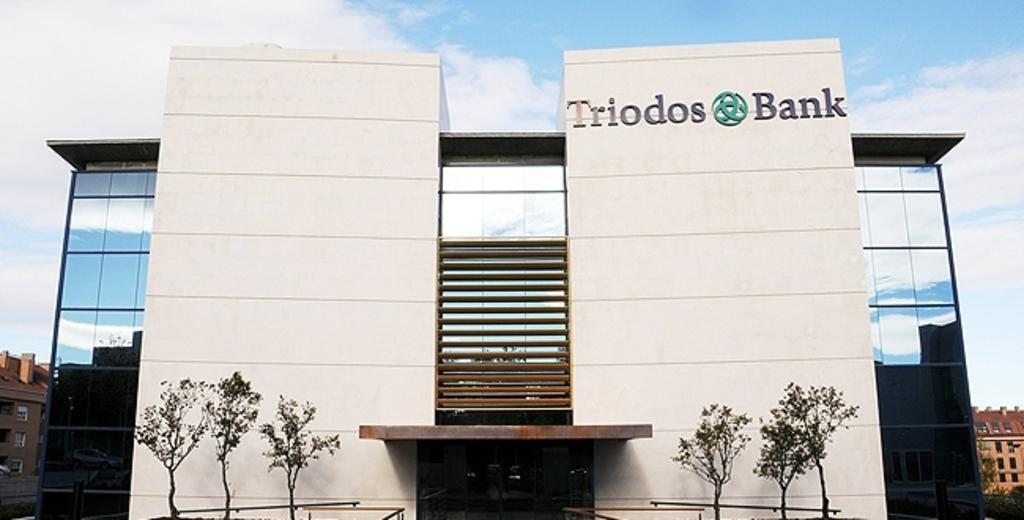What type of natural elements can be seen in the image? There are trees in the image. What type of man-made structures are present in the image? There are buildings with windows in the image. Can you describe any objects visible in the image? Yes, there are objects in the image. What can be seen in the background of the image? The sky is visible in the background of the image. What is the condition of the sky in the image? Clouds are present in the sky. Is there a slope visible in the image? There is no slope present in the image. How many matches are being used in the image? There are no matches visible in the image. 